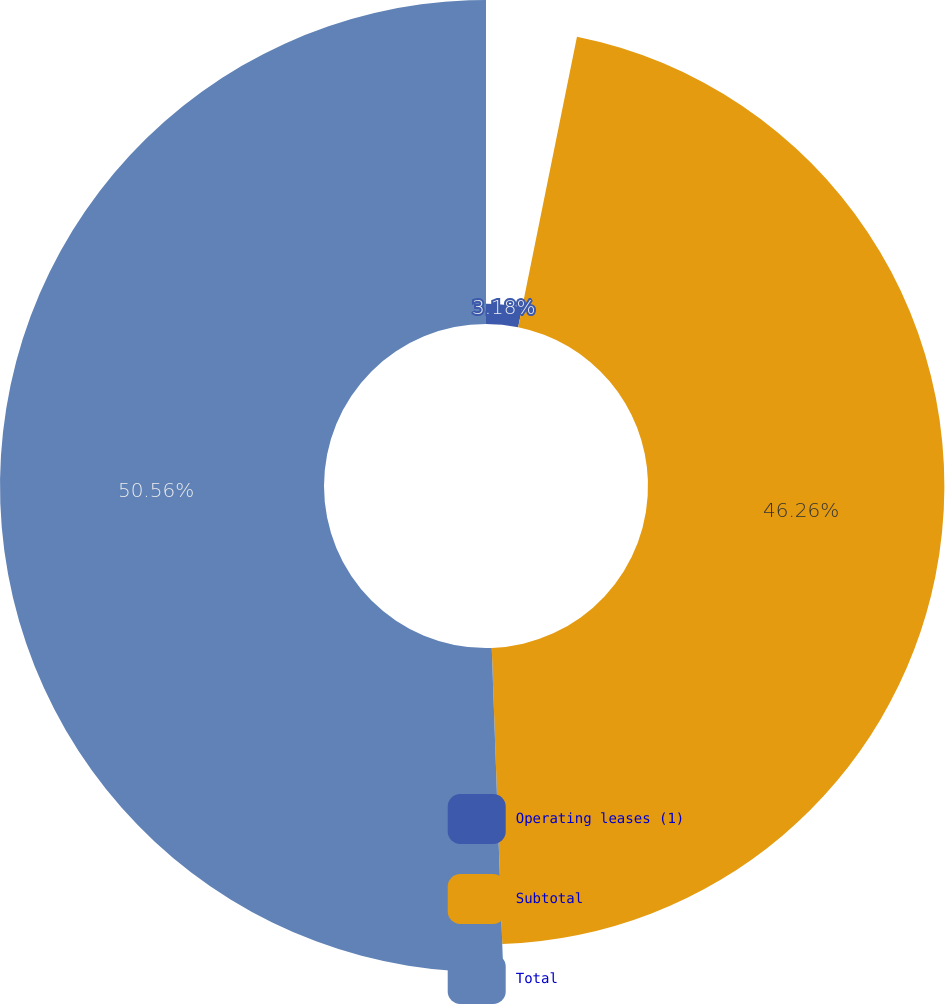Convert chart. <chart><loc_0><loc_0><loc_500><loc_500><pie_chart><fcel>Operating leases (1)<fcel>Subtotal<fcel>Total<nl><fcel>3.18%<fcel>46.26%<fcel>50.57%<nl></chart> 